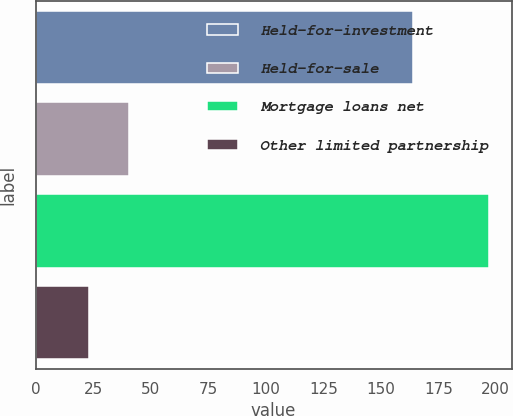Convert chart. <chart><loc_0><loc_0><loc_500><loc_500><bar_chart><fcel>Held-for-investment<fcel>Held-for-sale<fcel>Mortgage loans net<fcel>Other limited partnership<nl><fcel>164<fcel>40.4<fcel>197<fcel>23<nl></chart> 